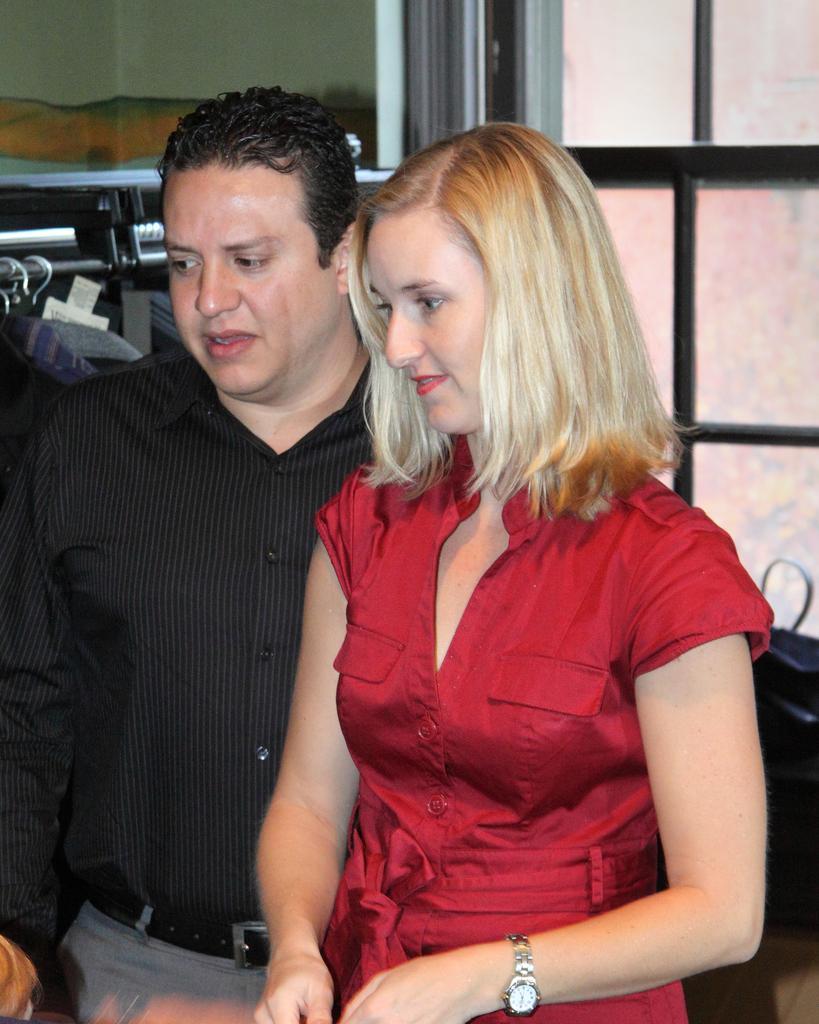Can you describe this image briefly? In this image we can see a woman wearing a red color dress and this man is wearing a black color shirt are standing here. In the background, we can see the glass windows and dresses hanged to the pole. 